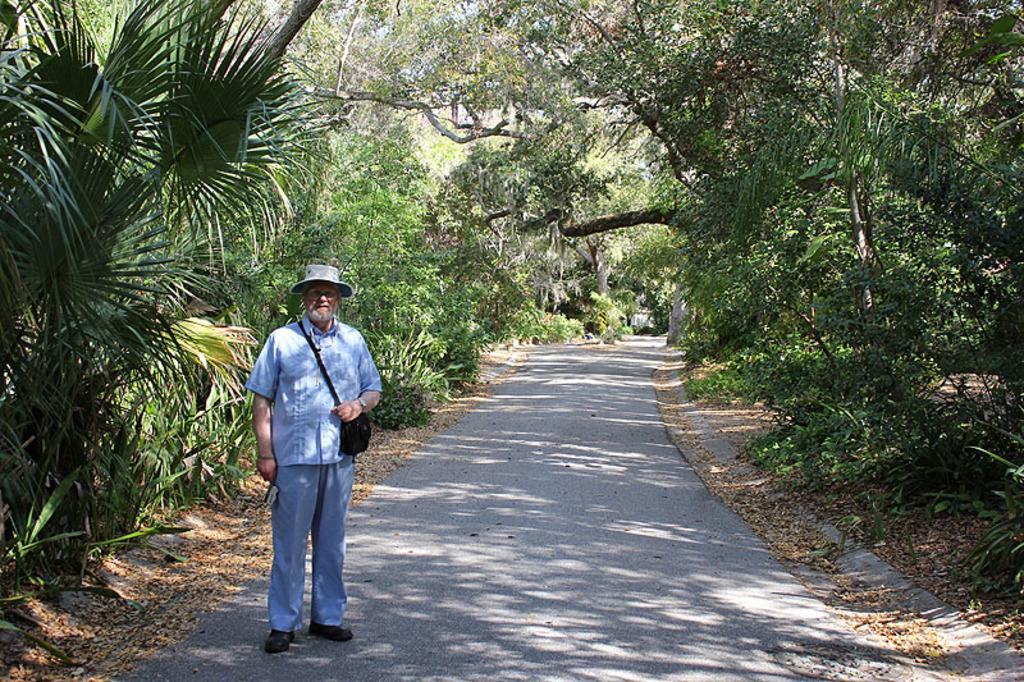What is the main subject of the image? The main subject of the image is a man standing on a road. What can be seen on either side of the road in the image? There are trees on either side of the road in the image. What type of rake is being used by the man in the image? There is no rake present in the image; the man is simply standing on the road. How many bridges can be seen crossing the road in the image? There are no bridges visible in the image; it only features a man standing on a road with trees on either side. 